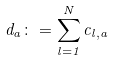<formula> <loc_0><loc_0><loc_500><loc_500>d _ { a } \colon = \sum _ { l = 1 } ^ { N } c _ { l , a }</formula> 